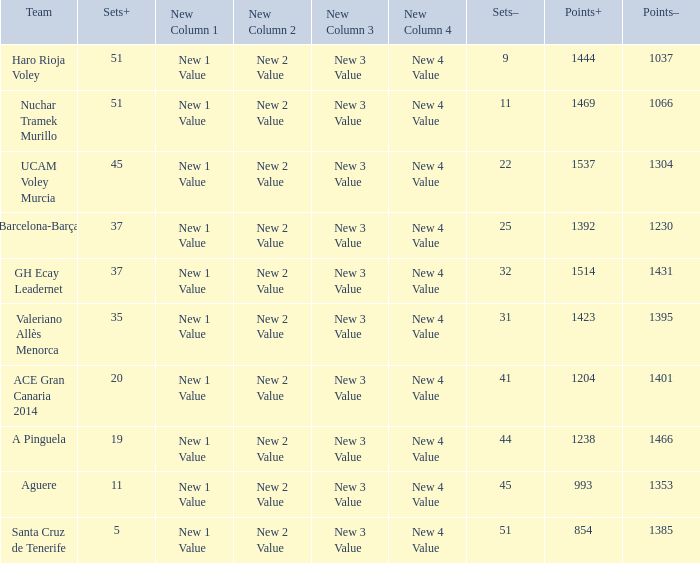What is the highest Sets+ number for Valeriano Allès Menorca when the Sets- number was larger than 31? None. 